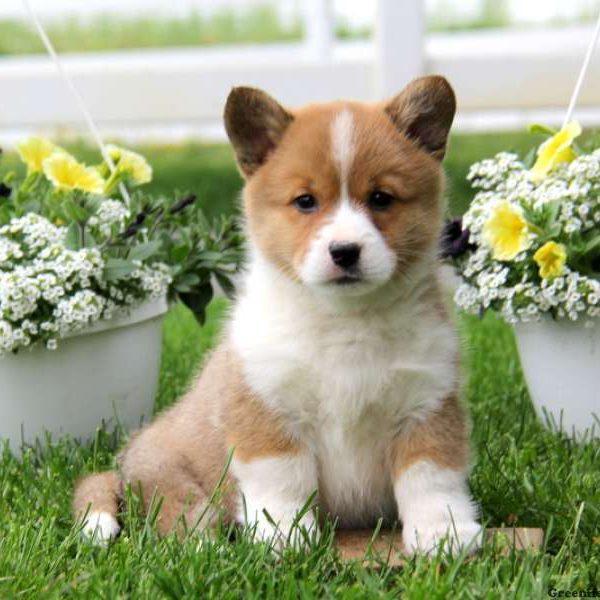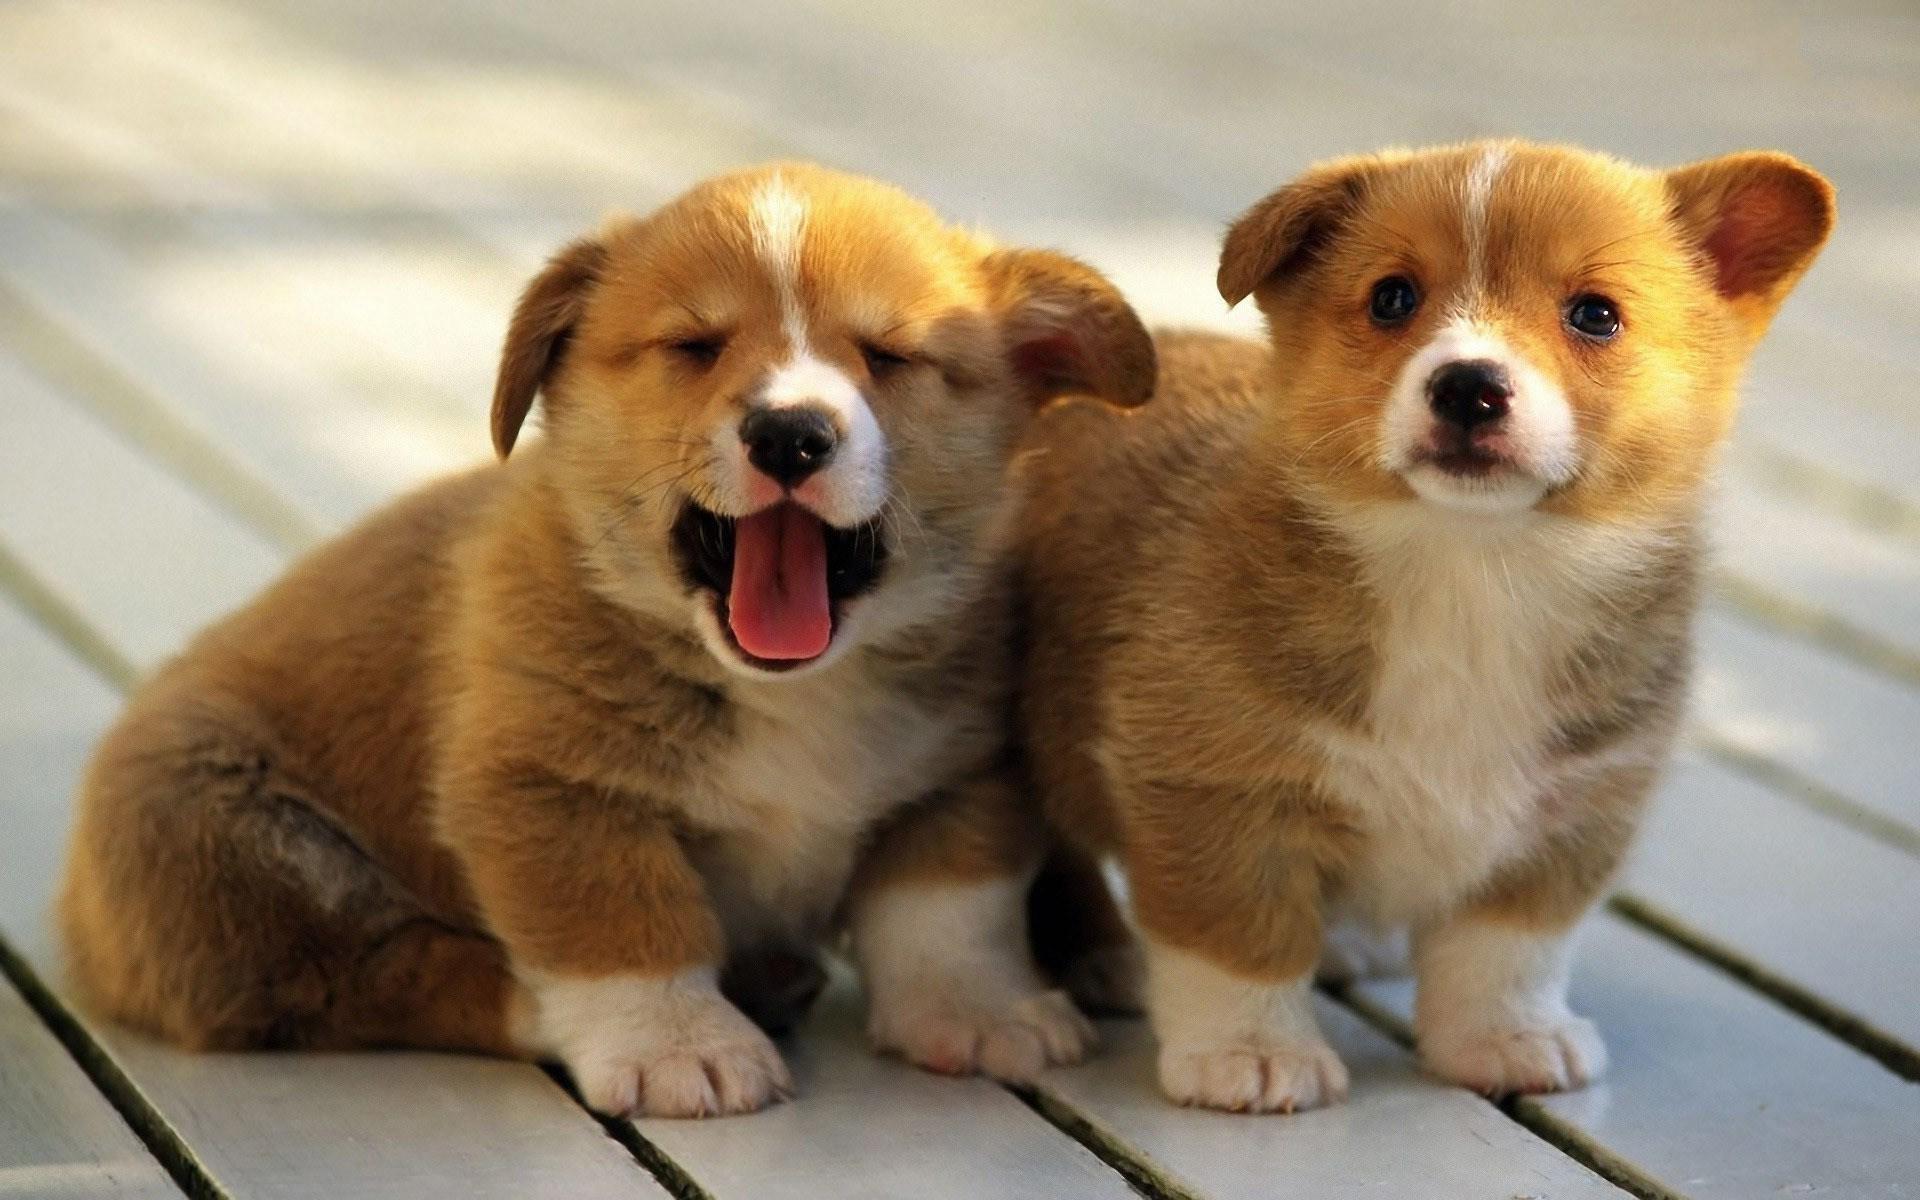The first image is the image on the left, the second image is the image on the right. Given the left and right images, does the statement "There are at least 5 dogs lying on the floor." hold true? Answer yes or no. No. The first image is the image on the left, the second image is the image on the right. Assess this claim about the two images: "All of the dogs are lying down, either on their bellies or on their backs, but not on their side.". Correct or not? Answer yes or no. No. 